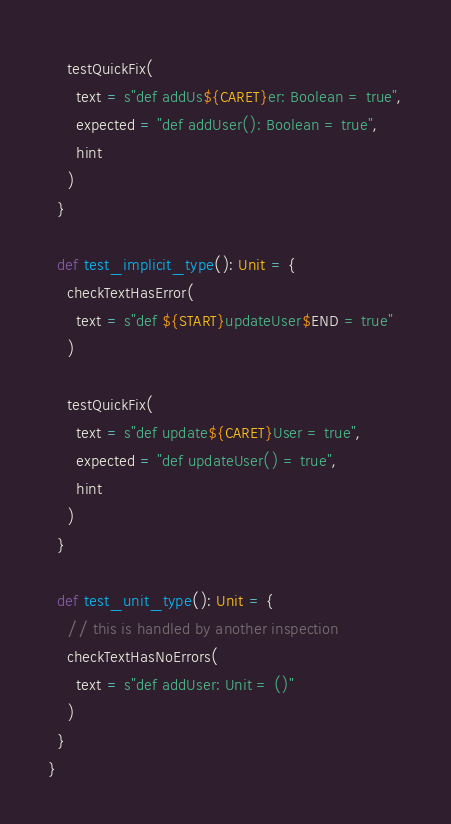<code> <loc_0><loc_0><loc_500><loc_500><_Scala_>
    testQuickFix(
      text = s"def addUs${CARET}er: Boolean = true",
      expected = "def addUser(): Boolean = true",
      hint
    )
  }

  def test_implicit_type(): Unit = {
    checkTextHasError(
      text = s"def ${START}updateUser$END = true"
    )

    testQuickFix(
      text = s"def update${CARET}User = true",
      expected = "def updateUser() = true",
      hint
    )
  }

  def test_unit_type(): Unit = {
    // this is handled by another inspection
    checkTextHasNoErrors(
      text = s"def addUser: Unit = ()"
    )
  }
}
</code> 